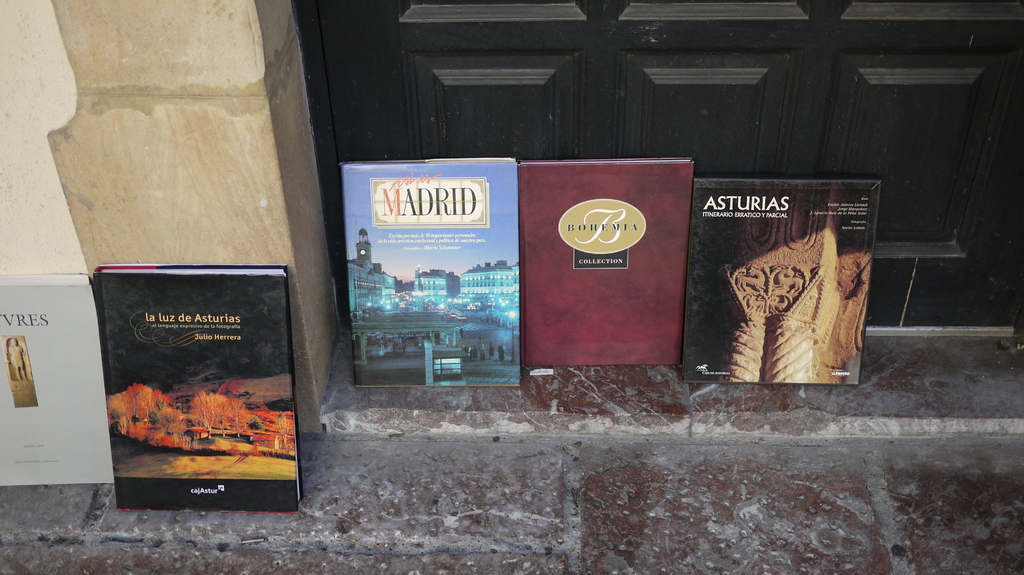What information do these books provide about Spain and its regions? Each book offers a unique glimpse into Spain's diverse regions: Madrid's book likely explores its vibrant city life and historical sites, while the Asturias book could discuss its natural landscapes and cultural heritage, providing travelers and enthusiasts with rich, detailed insights. 